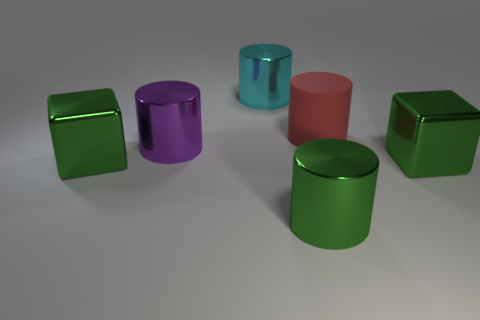Subtract 2 cylinders. How many cylinders are left? 2 Subtract all green cylinders. How many cylinders are left? 3 Subtract all large rubber cylinders. How many cylinders are left? 3 Add 2 large red cylinders. How many objects exist? 8 Subtract all yellow cylinders. Subtract all blue spheres. How many cylinders are left? 4 Subtract all blocks. How many objects are left? 4 Subtract all big rubber objects. Subtract all brown balls. How many objects are left? 5 Add 3 big cyan cylinders. How many big cyan cylinders are left? 4 Add 3 cyan objects. How many cyan objects exist? 4 Subtract 0 yellow cylinders. How many objects are left? 6 